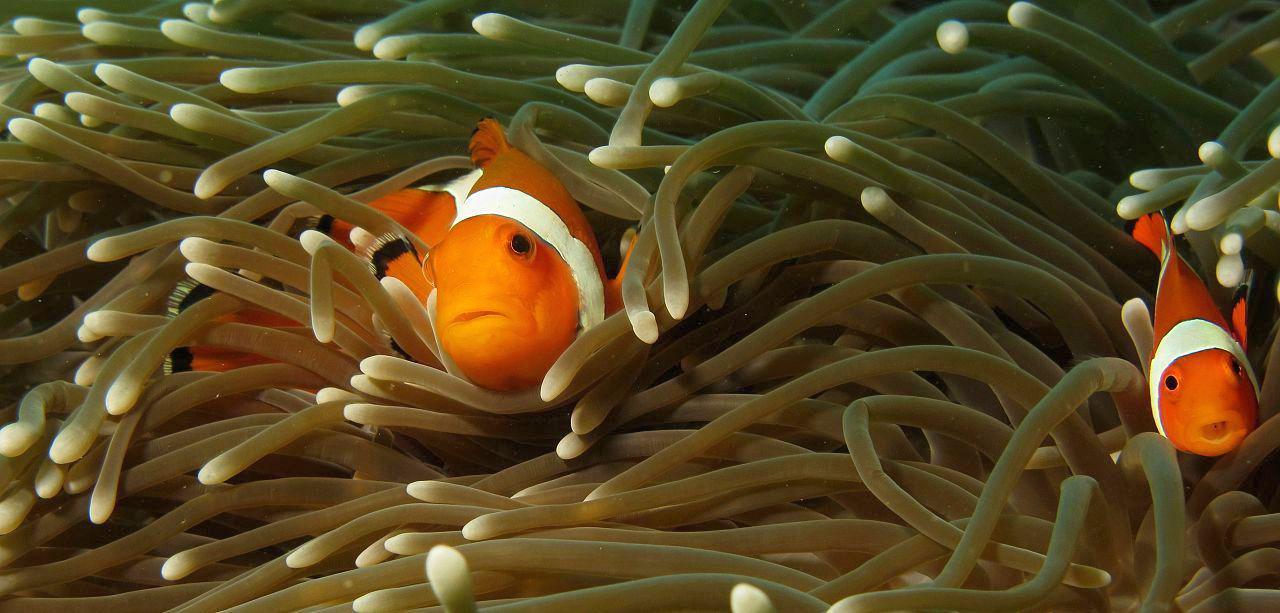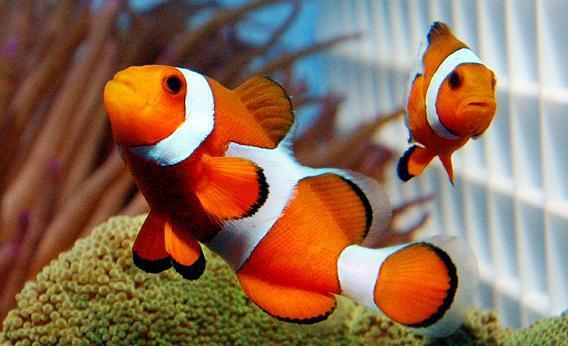The first image is the image on the left, the second image is the image on the right. Evaluate the accuracy of this statement regarding the images: "There are three fish". Is it true? Answer yes or no. No. The first image is the image on the left, the second image is the image on the right. Assess this claim about the two images: "There is only one clownfish on the right image". Correct or not? Answer yes or no. No. 